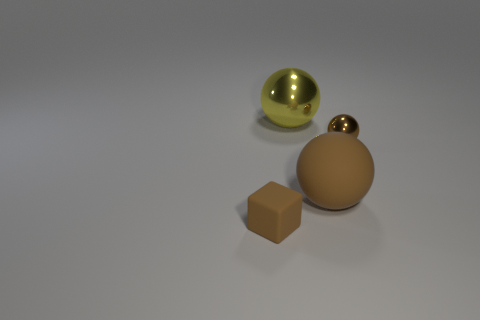Do the rubber object that is left of the big yellow ball and the shiny thing behind the small sphere have the same shape?
Ensure brevity in your answer.  No. There is a brown rubber object in front of the matte object that is behind the brown object left of the yellow thing; what shape is it?
Provide a succinct answer. Cube. What number of other objects are there of the same shape as the tiny matte thing?
Provide a short and direct response. 0. There is a sphere that is the same size as the brown matte cube; what is its color?
Your answer should be compact. Brown. How many balls are either tiny purple things or brown things?
Offer a terse response. 2. How many tiny cyan shiny spheres are there?
Give a very brief answer. 0. Does the big brown thing have the same shape as the small brown object that is to the right of the large yellow shiny sphere?
Your response must be concise. Yes. What size is the rubber block that is the same color as the tiny shiny thing?
Your answer should be very brief. Small. What number of things are big matte things or small red objects?
Keep it short and to the point. 1. The tiny brown object to the left of the small brown thing that is behind the tiny brown matte thing is what shape?
Offer a terse response. Cube. 